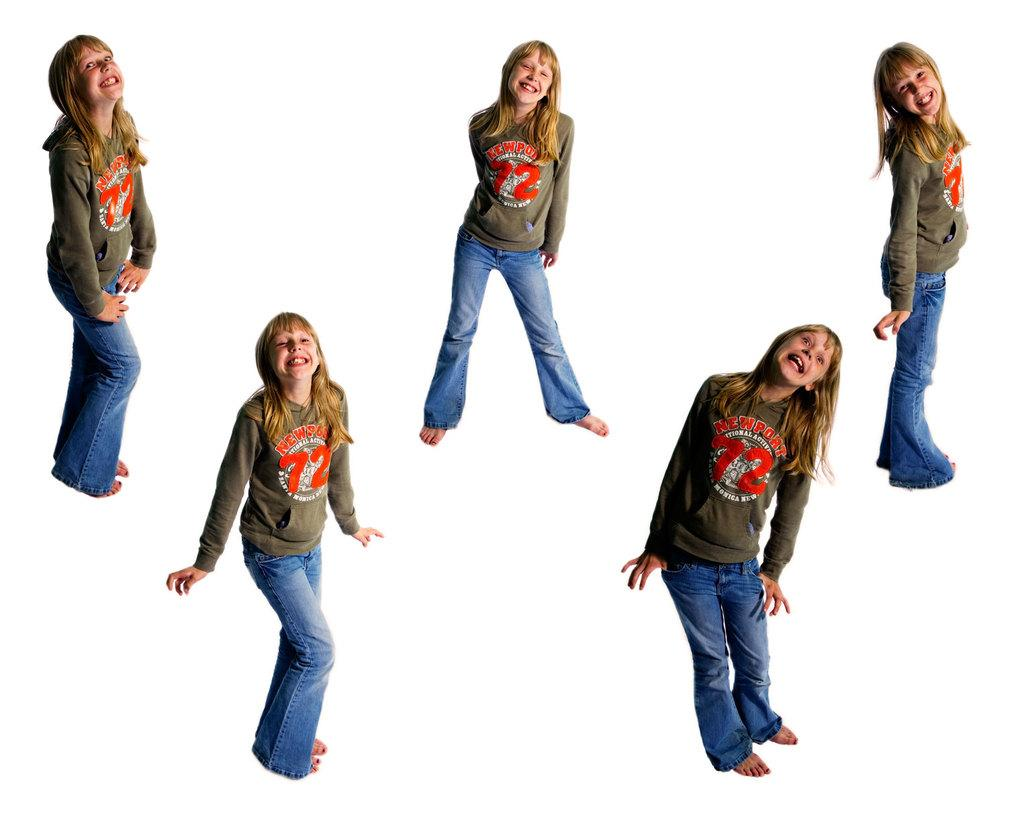What is the main subject of the image? The main subject of the image is a girl. How many representations of the girl are there in the image? There are multiple representations of the girl in the image. What can be observed about the girl's positions in the image? The girl is depicted in different positions. What type of committee is the girl a part of in the image? There is no committee present in the image, and the girl's involvement in any committee cannot be determined. 